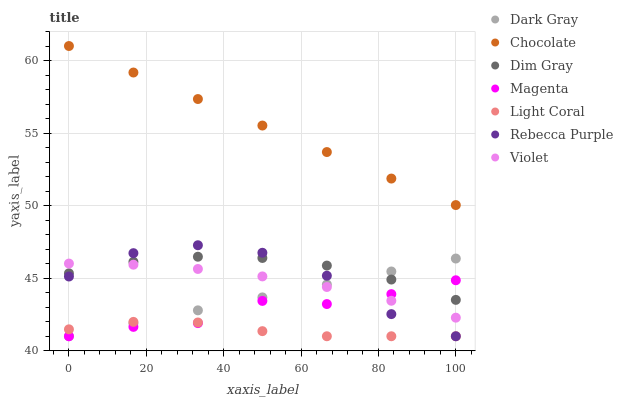Does Light Coral have the minimum area under the curve?
Answer yes or no. Yes. Does Chocolate have the maximum area under the curve?
Answer yes or no. Yes. Does Dim Gray have the minimum area under the curve?
Answer yes or no. No. Does Dim Gray have the maximum area under the curve?
Answer yes or no. No. Is Chocolate the smoothest?
Answer yes or no. Yes. Is Rebecca Purple the roughest?
Answer yes or no. Yes. Is Dim Gray the smoothest?
Answer yes or no. No. Is Dim Gray the roughest?
Answer yes or no. No. Does Light Coral have the lowest value?
Answer yes or no. Yes. Does Dim Gray have the lowest value?
Answer yes or no. No. Does Chocolate have the highest value?
Answer yes or no. Yes. Does Dim Gray have the highest value?
Answer yes or no. No. Is Light Coral less than Dim Gray?
Answer yes or no. Yes. Is Chocolate greater than Magenta?
Answer yes or no. Yes. Does Magenta intersect Violet?
Answer yes or no. Yes. Is Magenta less than Violet?
Answer yes or no. No. Is Magenta greater than Violet?
Answer yes or no. No. Does Light Coral intersect Dim Gray?
Answer yes or no. No. 